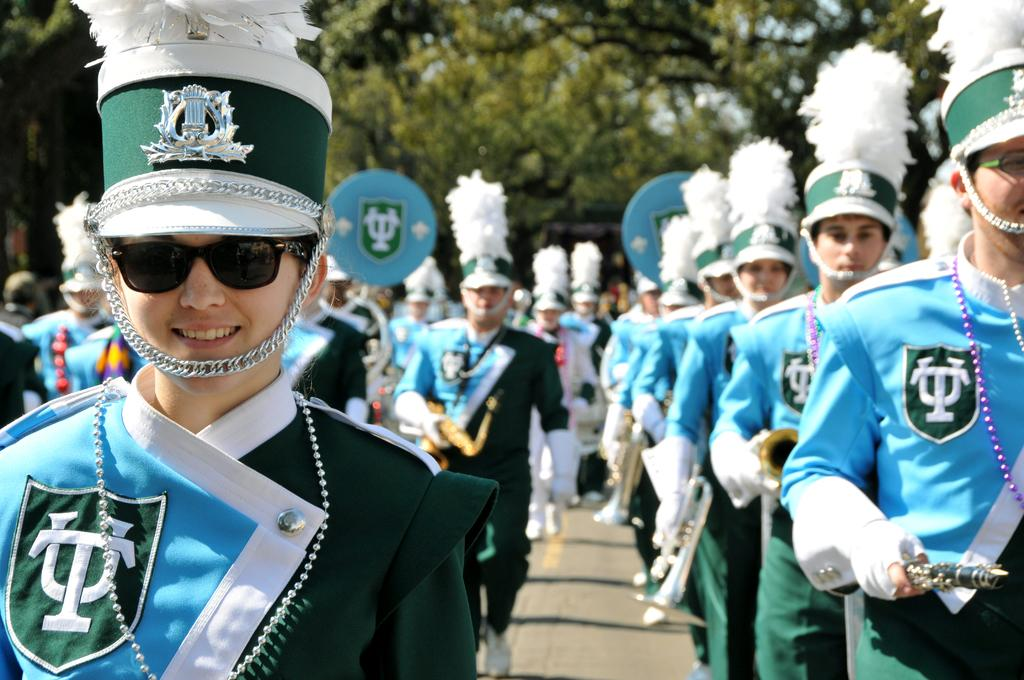What are the people in the image doing? The persons standing on the floor in the image are wearing uniforms. What can be seen in the background of the image? Trees and the sky are visible in the image. What type of silver flower is growing near the persons in the image? There is no silver flower present in the image. 